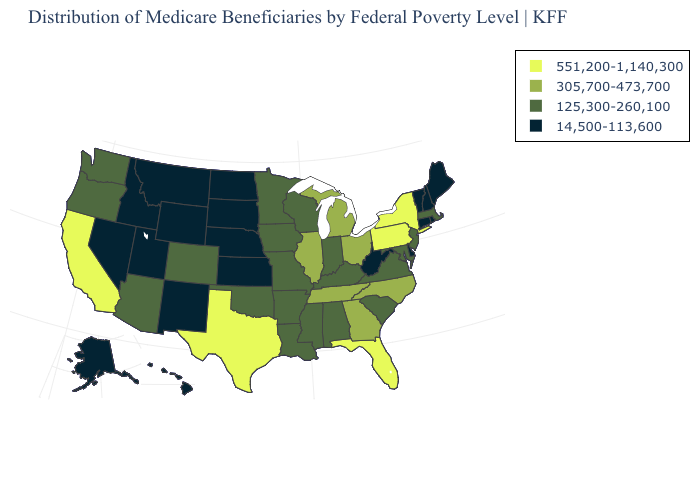What is the value of California?
Give a very brief answer. 551,200-1,140,300. What is the value of Alaska?
Give a very brief answer. 14,500-113,600. Which states have the lowest value in the West?
Concise answer only. Alaska, Hawaii, Idaho, Montana, Nevada, New Mexico, Utah, Wyoming. Among the states that border Mississippi , which have the highest value?
Keep it brief. Tennessee. Does Utah have the lowest value in the West?
Quick response, please. Yes. Which states have the lowest value in the South?
Concise answer only. Delaware, West Virginia. Does Vermont have the same value as Alabama?
Give a very brief answer. No. What is the value of Maine?
Be succinct. 14,500-113,600. Name the states that have a value in the range 551,200-1,140,300?
Keep it brief. California, Florida, New York, Pennsylvania, Texas. What is the value of Pennsylvania?
Keep it brief. 551,200-1,140,300. What is the lowest value in the USA?
Quick response, please. 14,500-113,600. Does Connecticut have the highest value in the Northeast?
Be succinct. No. Name the states that have a value in the range 14,500-113,600?
Write a very short answer. Alaska, Connecticut, Delaware, Hawaii, Idaho, Kansas, Maine, Montana, Nebraska, Nevada, New Hampshire, New Mexico, North Dakota, Rhode Island, South Dakota, Utah, Vermont, West Virginia, Wyoming. What is the value of Louisiana?
Keep it brief. 125,300-260,100. Does the map have missing data?
Be succinct. No. 